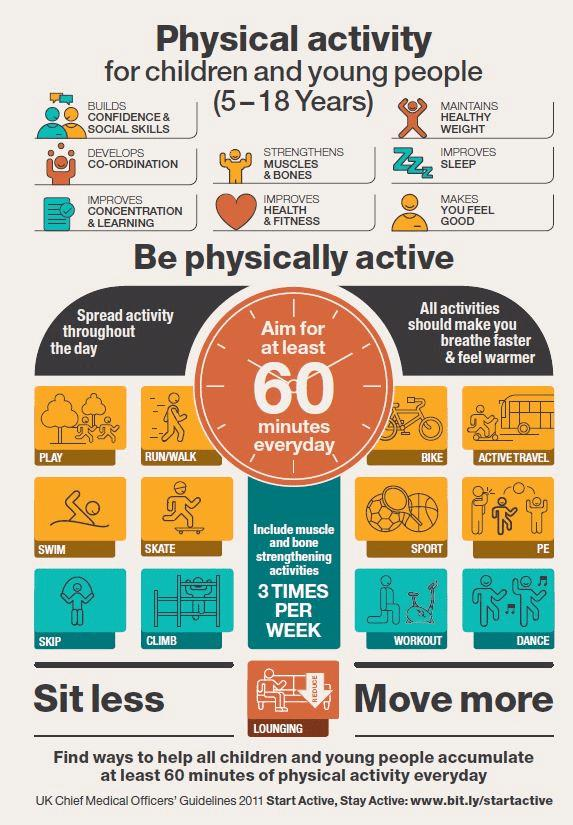Mention a couple of crucial points in this snapshot. Eight positive aspects of physical activity were mentioned in this infographic. There are 12 activities mentioned in this infographic. 